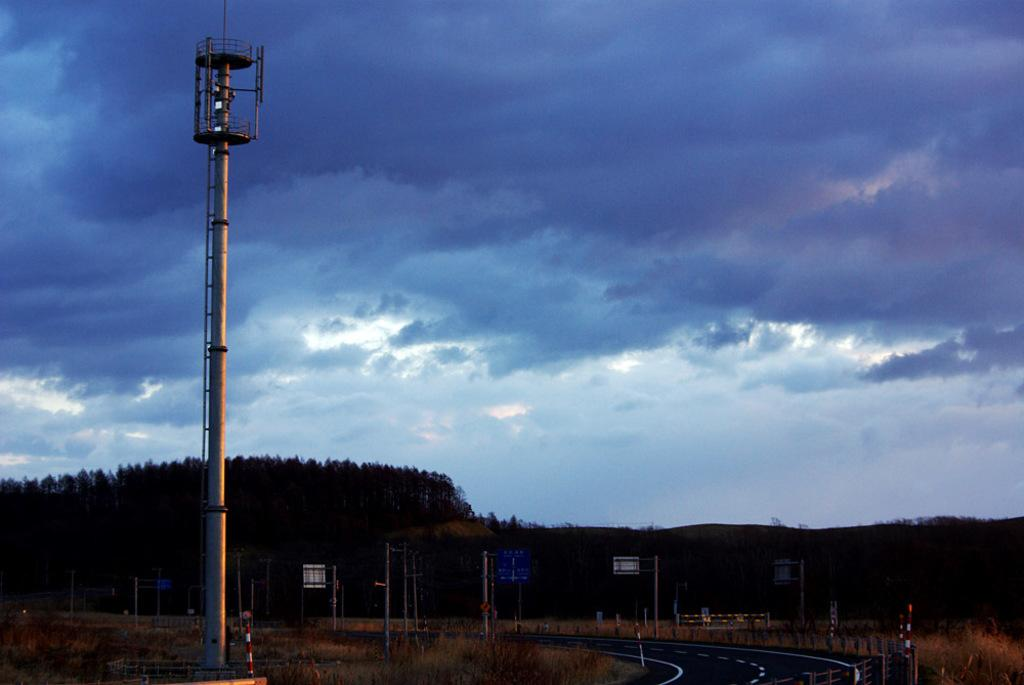What structures are present in the image? There are poles and boards in the image. What is located at the bottom of the image? There is a road and grass at the bottom of the image. What type of vegetation is behind the poles? There are trees behind the poles. How would you describe the sky in the image? The sky is cloudy in the image. How many hens can be seen playing with balls in the image? There are no hens or balls present in the image. 